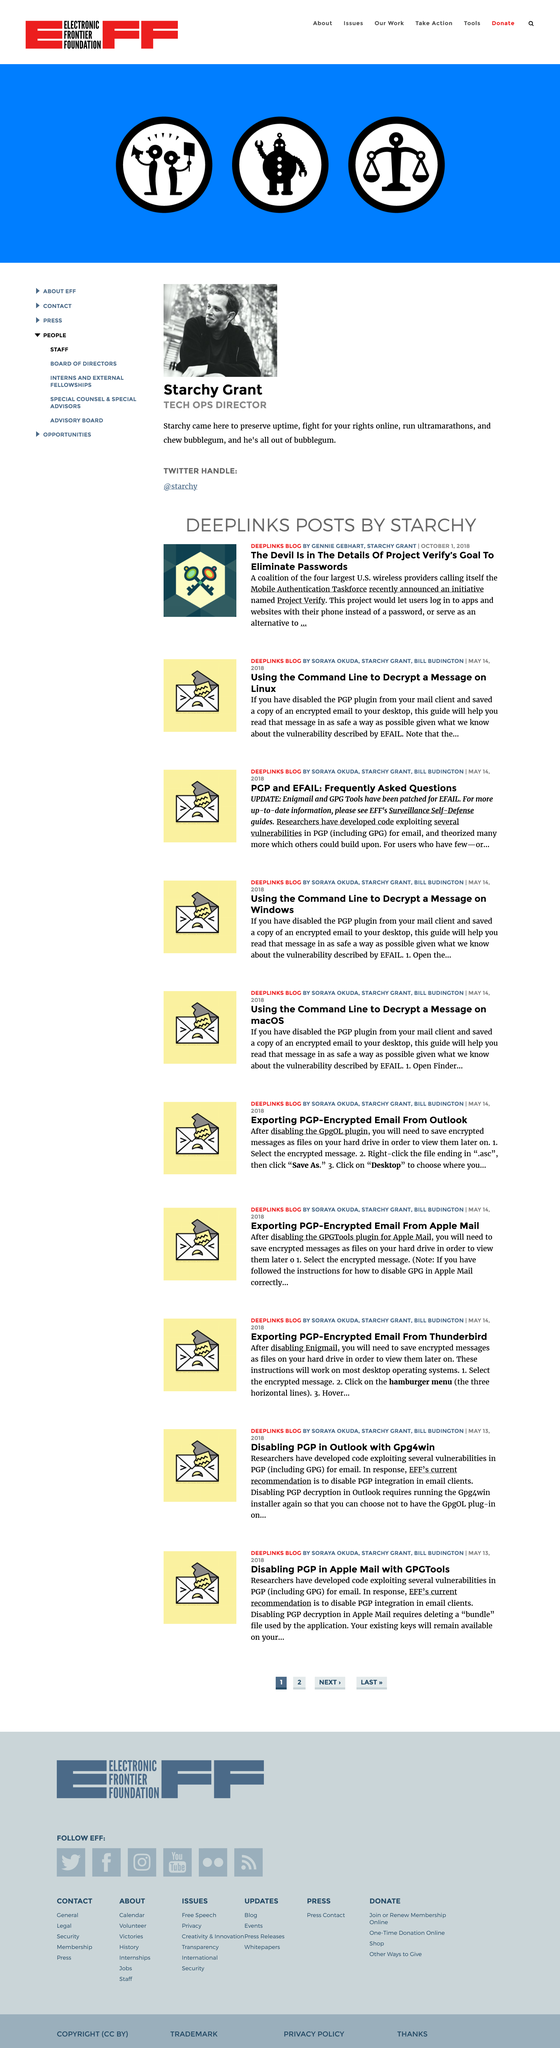Give some essential details in this illustration. The aim of Project Verify is to enable users to use their mobile devices to log into apps and websites, instead of traditional passwords. Starchy's full name is Starchy Grant. The title of the blog post authored by Gennie Gebhart and Starchy Grant is "The Devil is in the Details of Project Verify's Goal to Eliminate Passwords. 